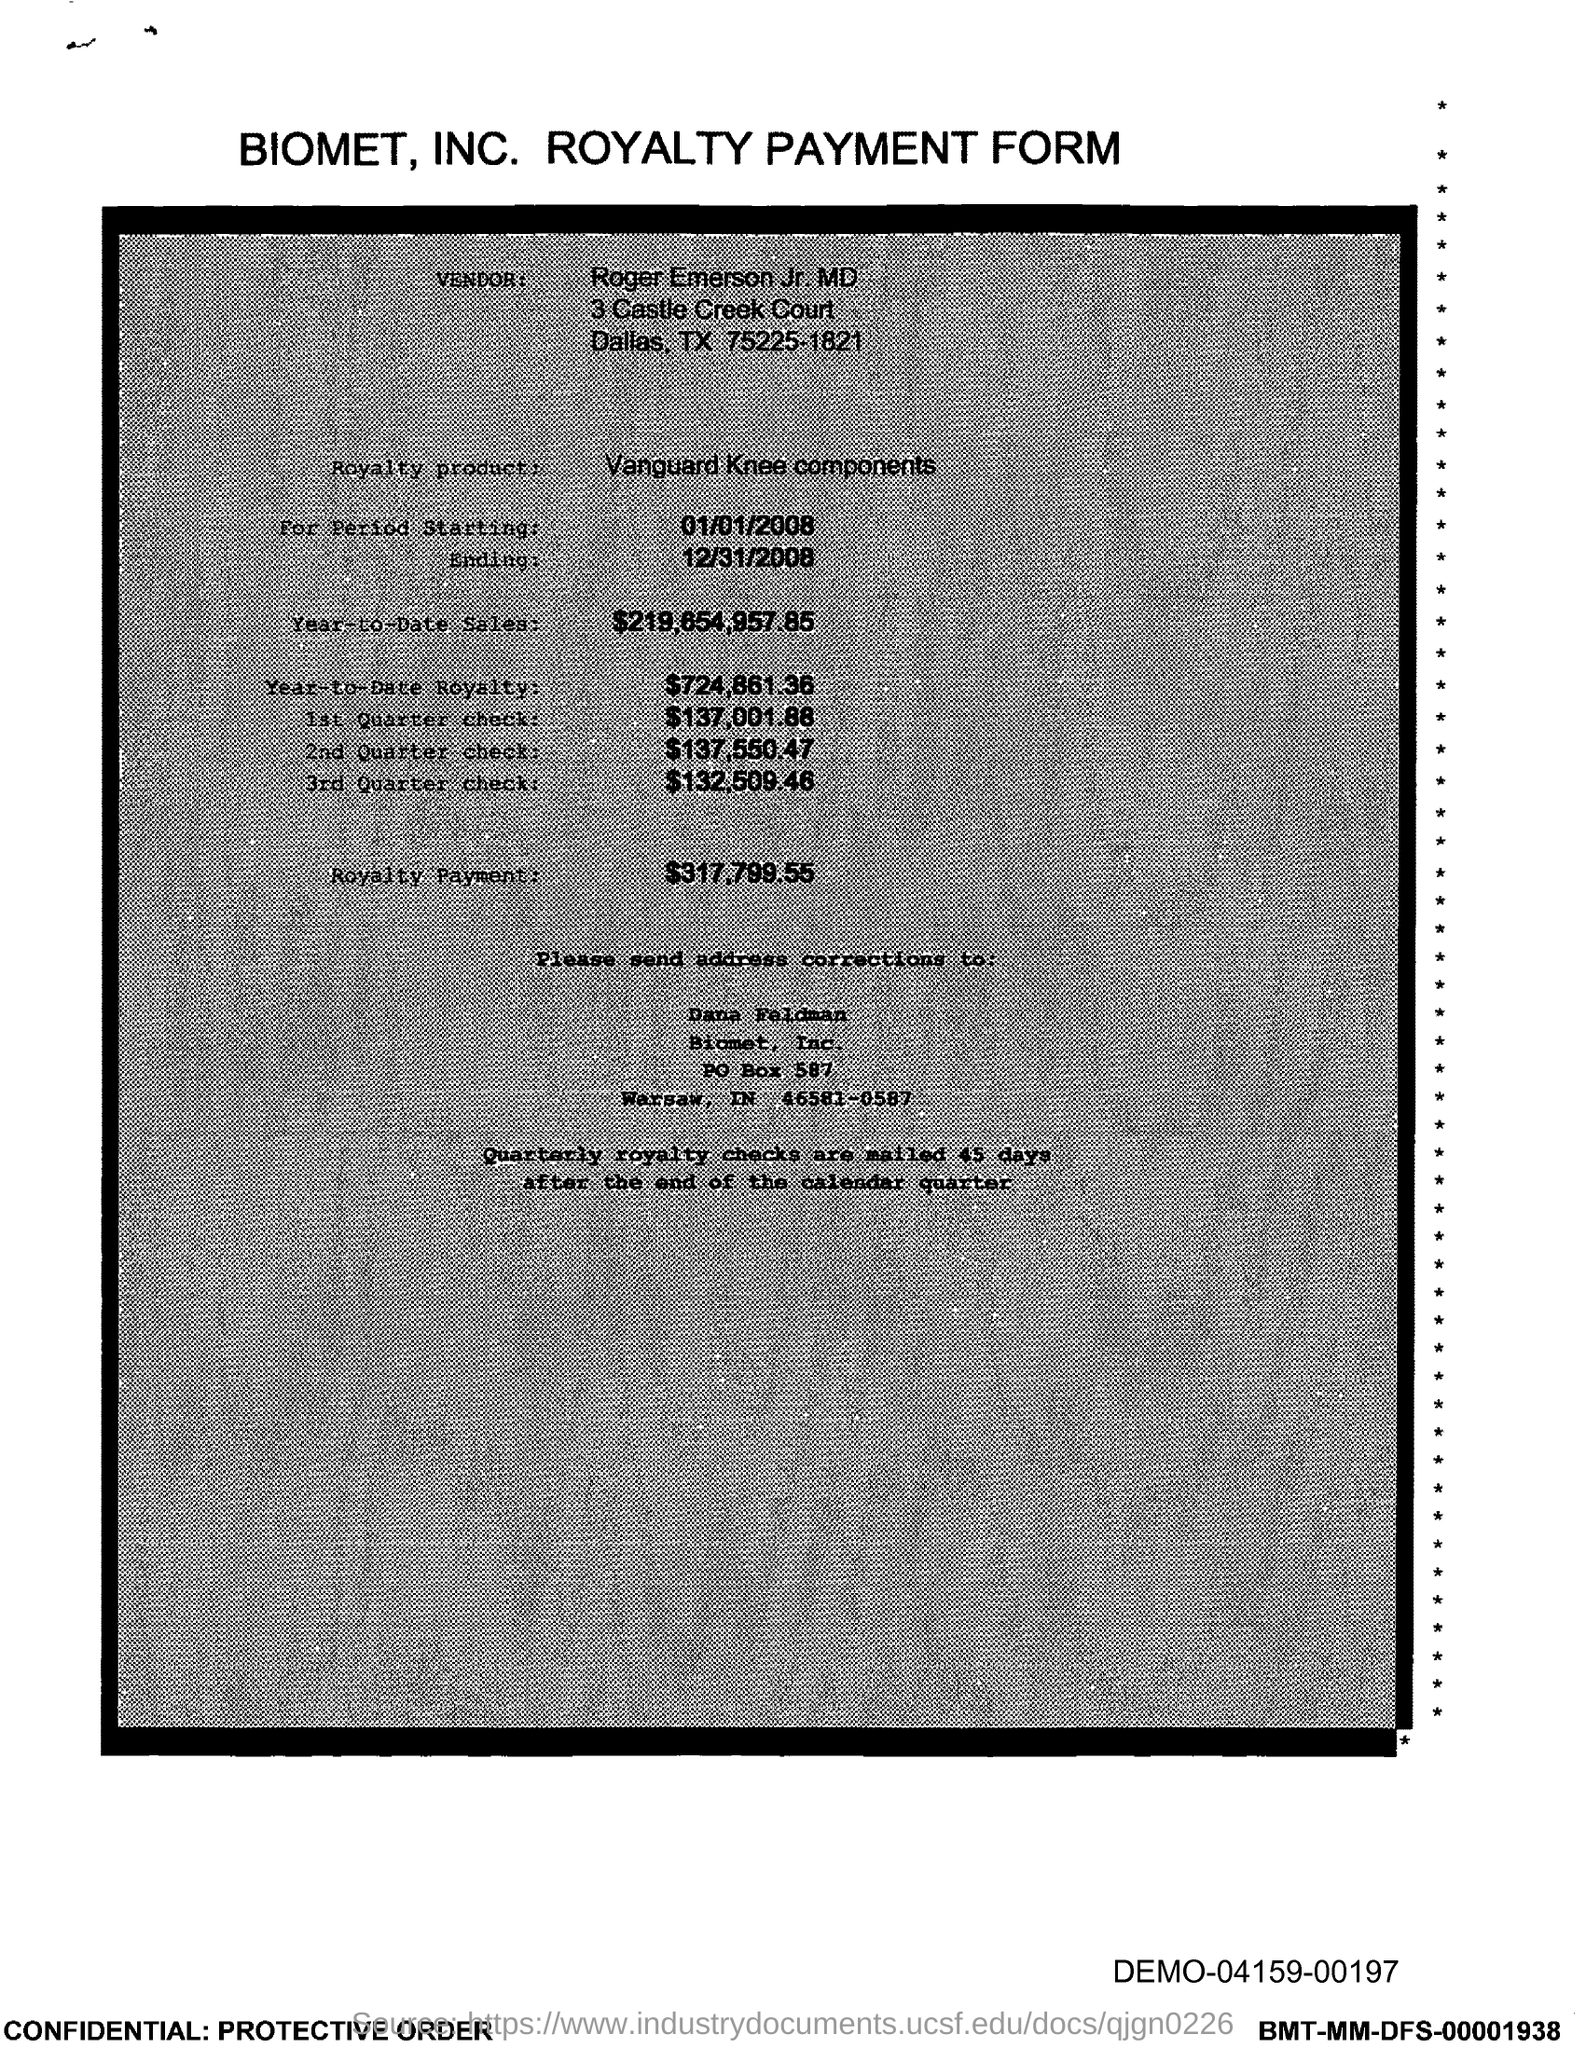Indicate a few pertinent items in this graphic. To whom should address corrections be sent? Dana Feldman should be the recipient of such corrections. The vendor is Roger Emerson. Vanguard Knee components are the royalty product mentioned. The royalty payment is $317,799.55. 